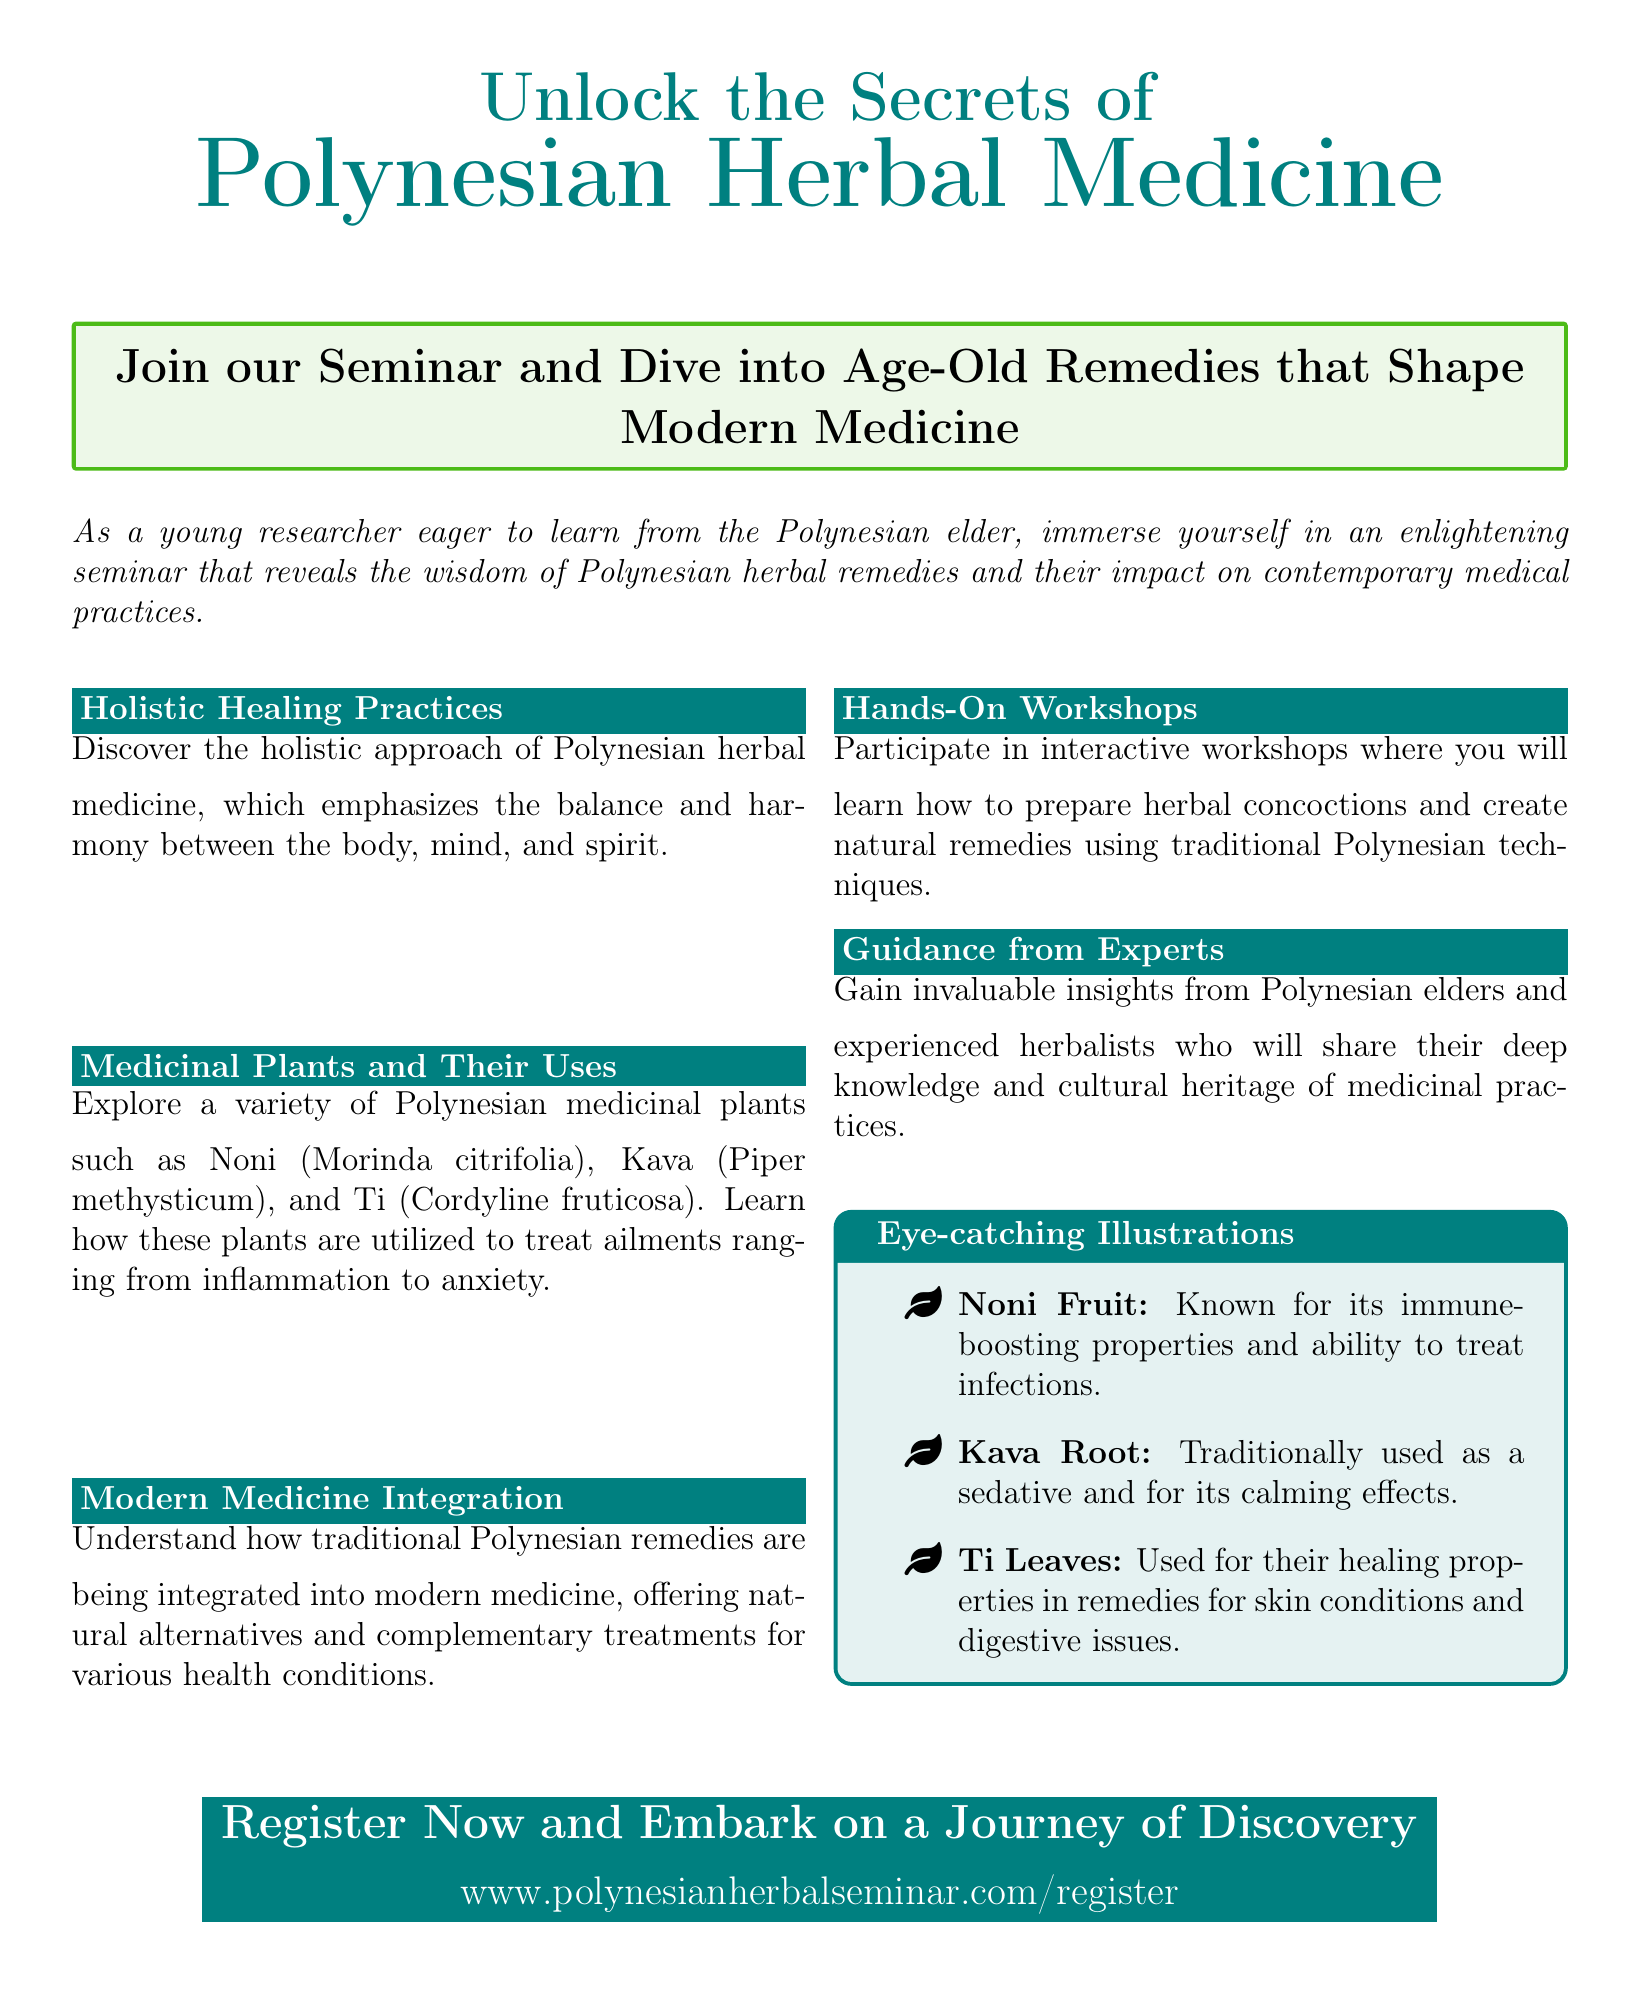What is the seminar about? The seminar focuses on Polynesian herbal medicine and the secrets of herbal remedies.
Answer: Polynesian herbal medicine Who is the target audience for the seminar? The text mentions young researchers eager to learn from Polynesian elders.
Answer: Young researchers What are some of the medicinal plants mentioned? The document lists specific plants used in the seminar context.
Answer: Noni, Kava, Ti How are traditional remedies integrated into modern practices? The section discusses the merging of ancient practices with contemporary medicine.
Answer: Modern medicine integration What type of interactive opportunities does the seminar offer? The document describes a hands-on experience for participants.
Answer: Workshops What is the website for registration? The document provides a specific URL for attendees to sign up for the seminar.
Answer: www.polynesianherbalseminar.com/register What kind of guidance will participants receive? The text mentions learning from experienced practitioners.
Answer: From Polynesian elders and experienced herbalists What is the purpose of the eye-catching illustrations? They are intended to highlight key medicinal plants and their uses.
Answer: To illustrate medicinal plants and their uses What kind of properties does Noni fruit have? The document details the benefits of specific medicinal plants.
Answer: Immune-boosting properties 